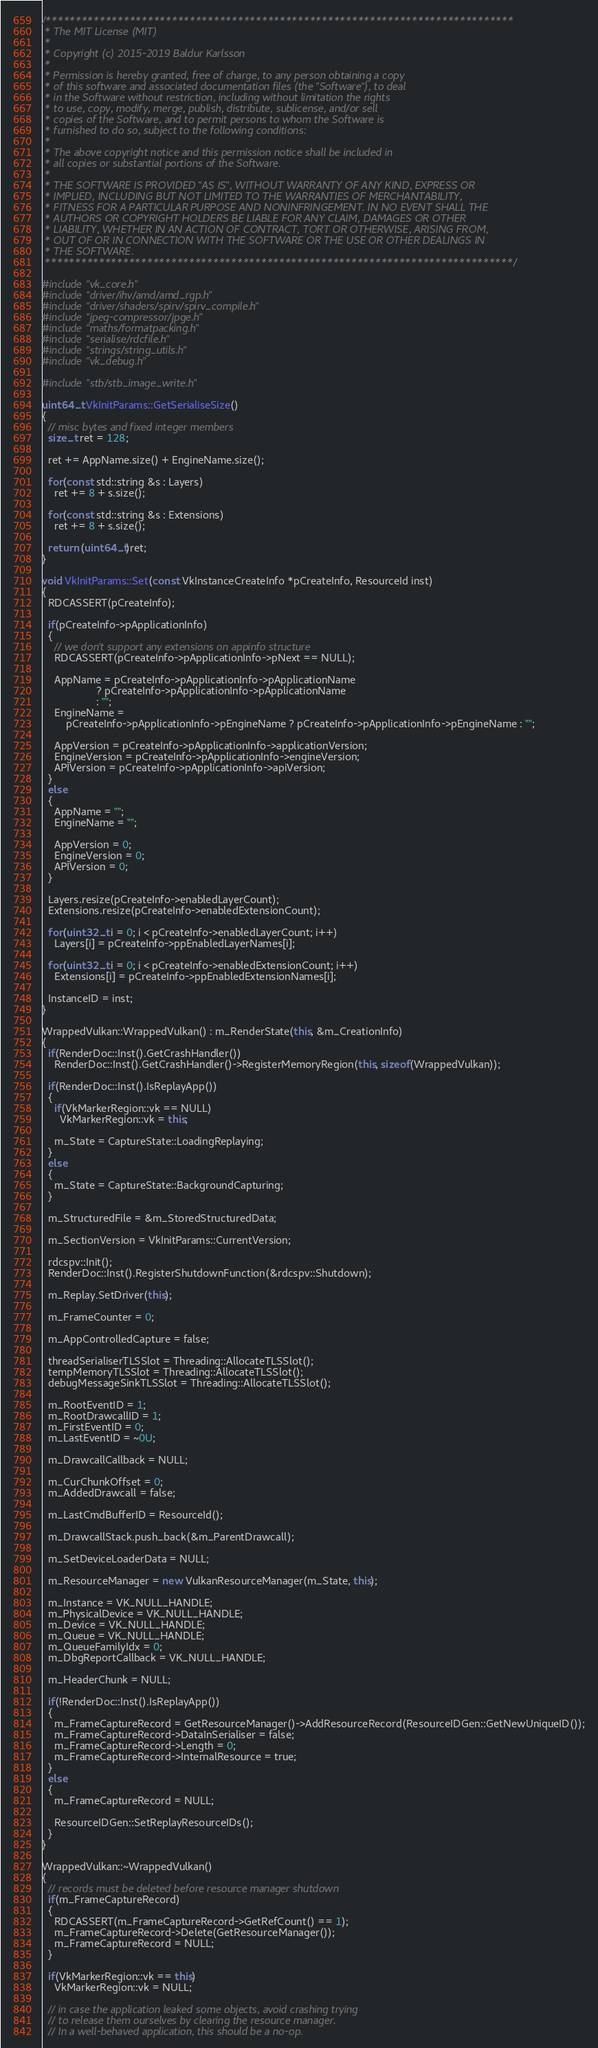<code> <loc_0><loc_0><loc_500><loc_500><_C++_>/******************************************************************************
 * The MIT License (MIT)
 *
 * Copyright (c) 2015-2019 Baldur Karlsson
 *
 * Permission is hereby granted, free of charge, to any person obtaining a copy
 * of this software and associated documentation files (the "Software"), to deal
 * in the Software without restriction, including without limitation the rights
 * to use, copy, modify, merge, publish, distribute, sublicense, and/or sell
 * copies of the Software, and to permit persons to whom the Software is
 * furnished to do so, subject to the following conditions:
 *
 * The above copyright notice and this permission notice shall be included in
 * all copies or substantial portions of the Software.
 *
 * THE SOFTWARE IS PROVIDED "AS IS", WITHOUT WARRANTY OF ANY KIND, EXPRESS OR
 * IMPLIED, INCLUDING BUT NOT LIMITED TO THE WARRANTIES OF MERCHANTABILITY,
 * FITNESS FOR A PARTICULAR PURPOSE AND NONINFRINGEMENT. IN NO EVENT SHALL THE
 * AUTHORS OR COPYRIGHT HOLDERS BE LIABLE FOR ANY CLAIM, DAMAGES OR OTHER
 * LIABILITY, WHETHER IN AN ACTION OF CONTRACT, TORT OR OTHERWISE, ARISING FROM,
 * OUT OF OR IN CONNECTION WITH THE SOFTWARE OR THE USE OR OTHER DEALINGS IN
 * THE SOFTWARE.
 ******************************************************************************/

#include "vk_core.h"
#include "driver/ihv/amd/amd_rgp.h"
#include "driver/shaders/spirv/spirv_compile.h"
#include "jpeg-compressor/jpge.h"
#include "maths/formatpacking.h"
#include "serialise/rdcfile.h"
#include "strings/string_utils.h"
#include "vk_debug.h"

#include "stb/stb_image_write.h"

uint64_t VkInitParams::GetSerialiseSize()
{
  // misc bytes and fixed integer members
  size_t ret = 128;

  ret += AppName.size() + EngineName.size();

  for(const std::string &s : Layers)
    ret += 8 + s.size();

  for(const std::string &s : Extensions)
    ret += 8 + s.size();

  return (uint64_t)ret;
}

void VkInitParams::Set(const VkInstanceCreateInfo *pCreateInfo, ResourceId inst)
{
  RDCASSERT(pCreateInfo);

  if(pCreateInfo->pApplicationInfo)
  {
    // we don't support any extensions on appinfo structure
    RDCASSERT(pCreateInfo->pApplicationInfo->pNext == NULL);

    AppName = pCreateInfo->pApplicationInfo->pApplicationName
                  ? pCreateInfo->pApplicationInfo->pApplicationName
                  : "";
    EngineName =
        pCreateInfo->pApplicationInfo->pEngineName ? pCreateInfo->pApplicationInfo->pEngineName : "";

    AppVersion = pCreateInfo->pApplicationInfo->applicationVersion;
    EngineVersion = pCreateInfo->pApplicationInfo->engineVersion;
    APIVersion = pCreateInfo->pApplicationInfo->apiVersion;
  }
  else
  {
    AppName = "";
    EngineName = "";

    AppVersion = 0;
    EngineVersion = 0;
    APIVersion = 0;
  }

  Layers.resize(pCreateInfo->enabledLayerCount);
  Extensions.resize(pCreateInfo->enabledExtensionCount);

  for(uint32_t i = 0; i < pCreateInfo->enabledLayerCount; i++)
    Layers[i] = pCreateInfo->ppEnabledLayerNames[i];

  for(uint32_t i = 0; i < pCreateInfo->enabledExtensionCount; i++)
    Extensions[i] = pCreateInfo->ppEnabledExtensionNames[i];

  InstanceID = inst;
}

WrappedVulkan::WrappedVulkan() : m_RenderState(this, &m_CreationInfo)
{
  if(RenderDoc::Inst().GetCrashHandler())
    RenderDoc::Inst().GetCrashHandler()->RegisterMemoryRegion(this, sizeof(WrappedVulkan));

  if(RenderDoc::Inst().IsReplayApp())
  {
    if(VkMarkerRegion::vk == NULL)
      VkMarkerRegion::vk = this;

    m_State = CaptureState::LoadingReplaying;
  }
  else
  {
    m_State = CaptureState::BackgroundCapturing;
  }

  m_StructuredFile = &m_StoredStructuredData;

  m_SectionVersion = VkInitParams::CurrentVersion;

  rdcspv::Init();
  RenderDoc::Inst().RegisterShutdownFunction(&rdcspv::Shutdown);

  m_Replay.SetDriver(this);

  m_FrameCounter = 0;

  m_AppControlledCapture = false;

  threadSerialiserTLSSlot = Threading::AllocateTLSSlot();
  tempMemoryTLSSlot = Threading::AllocateTLSSlot();
  debugMessageSinkTLSSlot = Threading::AllocateTLSSlot();

  m_RootEventID = 1;
  m_RootDrawcallID = 1;
  m_FirstEventID = 0;
  m_LastEventID = ~0U;

  m_DrawcallCallback = NULL;

  m_CurChunkOffset = 0;
  m_AddedDrawcall = false;

  m_LastCmdBufferID = ResourceId();

  m_DrawcallStack.push_back(&m_ParentDrawcall);

  m_SetDeviceLoaderData = NULL;

  m_ResourceManager = new VulkanResourceManager(m_State, this);

  m_Instance = VK_NULL_HANDLE;
  m_PhysicalDevice = VK_NULL_HANDLE;
  m_Device = VK_NULL_HANDLE;
  m_Queue = VK_NULL_HANDLE;
  m_QueueFamilyIdx = 0;
  m_DbgReportCallback = VK_NULL_HANDLE;

  m_HeaderChunk = NULL;

  if(!RenderDoc::Inst().IsReplayApp())
  {
    m_FrameCaptureRecord = GetResourceManager()->AddResourceRecord(ResourceIDGen::GetNewUniqueID());
    m_FrameCaptureRecord->DataInSerialiser = false;
    m_FrameCaptureRecord->Length = 0;
    m_FrameCaptureRecord->InternalResource = true;
  }
  else
  {
    m_FrameCaptureRecord = NULL;

    ResourceIDGen::SetReplayResourceIDs();
  }
}

WrappedVulkan::~WrappedVulkan()
{
  // records must be deleted before resource manager shutdown
  if(m_FrameCaptureRecord)
  {
    RDCASSERT(m_FrameCaptureRecord->GetRefCount() == 1);
    m_FrameCaptureRecord->Delete(GetResourceManager());
    m_FrameCaptureRecord = NULL;
  }

  if(VkMarkerRegion::vk == this)
    VkMarkerRegion::vk = NULL;

  // in case the application leaked some objects, avoid crashing trying
  // to release them ourselves by clearing the resource manager.
  // In a well-behaved application, this should be a no-op.</code> 